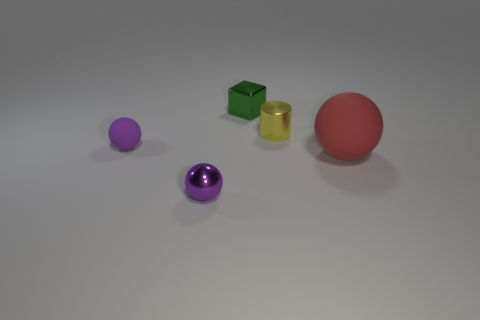Add 3 tiny gray metallic objects. How many objects exist? 8 Subtract all cubes. How many objects are left? 4 Subtract 0 red cylinders. How many objects are left? 5 Subtract all shiny cubes. Subtract all tiny purple matte things. How many objects are left? 3 Add 4 shiny spheres. How many shiny spheres are left? 5 Add 4 big green objects. How many big green objects exist? 4 